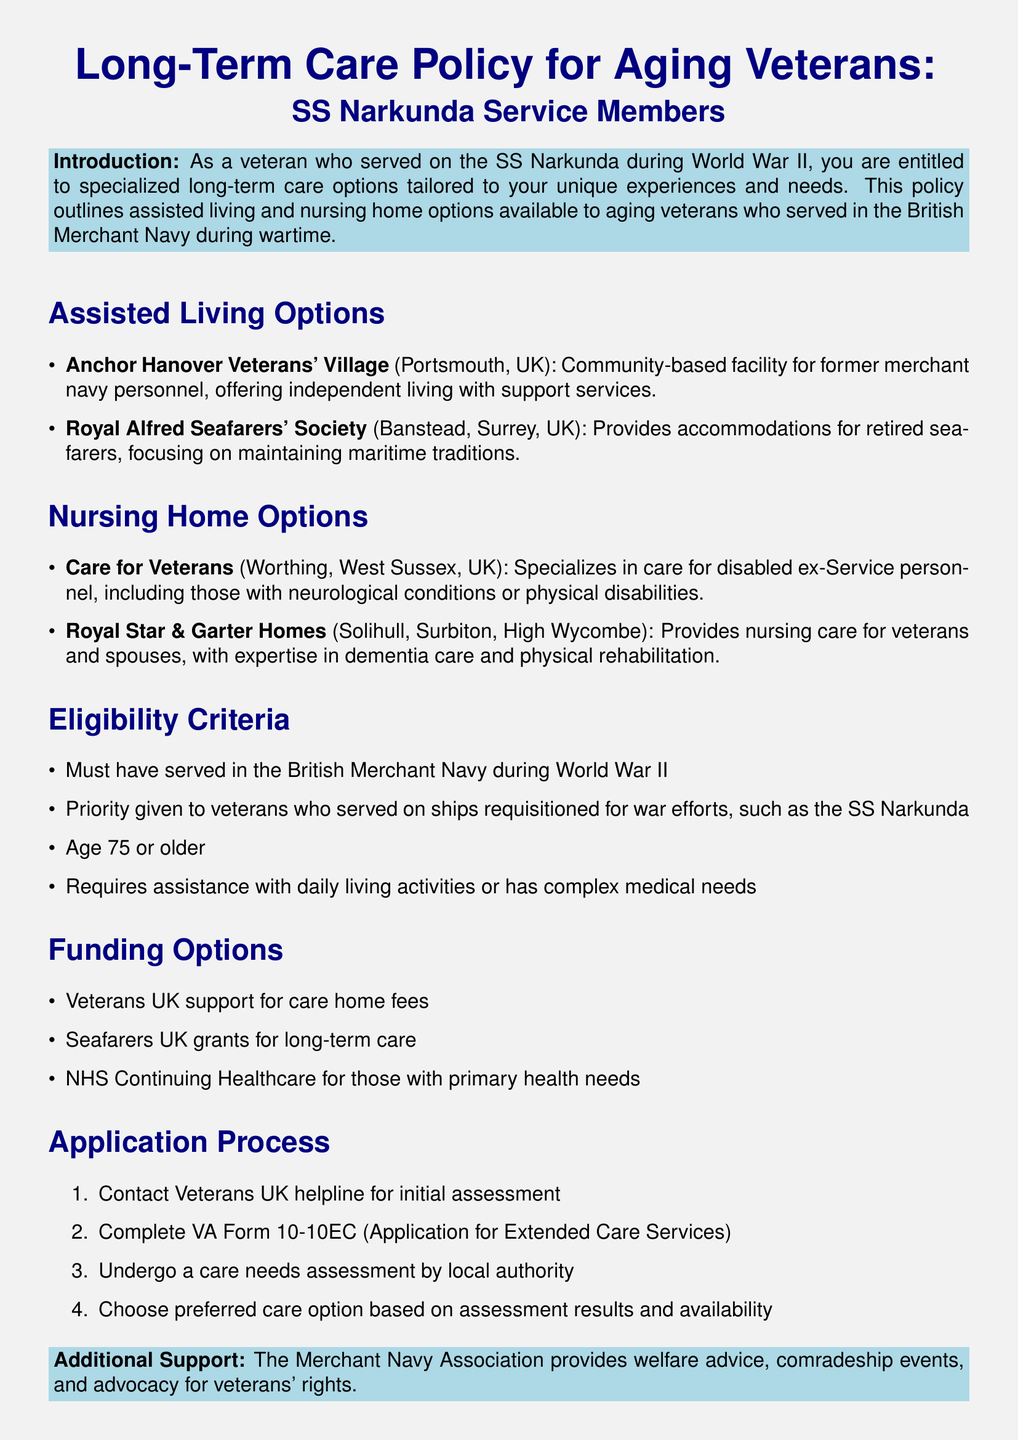What is the name of the assisted living option in Portsmouth? The document lists "Anchor Hanover Veterans' Village" as the assisted living option in Portsmouth.
Answer: Anchor Hanover Veterans' Village Which nursing home specializes in care for veterans with neurological conditions? The nursing home that specializes in this care is "Care for Veterans" located in Worthing.
Answer: Care for Veterans What age must a veteran be to be eligible for the long-term care options? The eligibility criteria states that the veteran must be 75 years or older.
Answer: 75 Which organization provides welfare advice and advocacy for veterans' rights? The document mentions that the "Merchant Navy Association" provides welfare advice and advocacy.
Answer: Merchant Navy Association What is the first step in the application process for long-term care services? According to the document, the first step is to "Contact Veterans UK helpline for initial assessment."
Answer: Contact Veterans UK helpline 